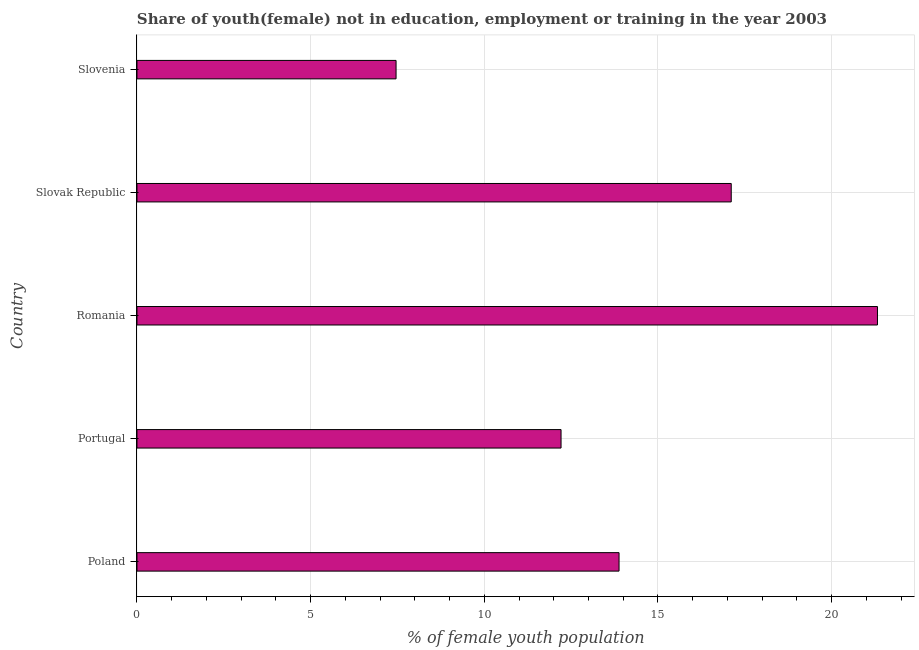Does the graph contain any zero values?
Keep it short and to the point. No. Does the graph contain grids?
Provide a short and direct response. Yes. What is the title of the graph?
Keep it short and to the point. Share of youth(female) not in education, employment or training in the year 2003. What is the label or title of the X-axis?
Your response must be concise. % of female youth population. What is the label or title of the Y-axis?
Make the answer very short. Country. What is the unemployed female youth population in Slovenia?
Provide a short and direct response. 7.46. Across all countries, what is the maximum unemployed female youth population?
Provide a short and direct response. 21.32. Across all countries, what is the minimum unemployed female youth population?
Provide a short and direct response. 7.46. In which country was the unemployed female youth population maximum?
Offer a terse response. Romania. In which country was the unemployed female youth population minimum?
Provide a short and direct response. Slovenia. What is the sum of the unemployed female youth population?
Provide a short and direct response. 71.98. What is the difference between the unemployed female youth population in Poland and Slovak Republic?
Your answer should be very brief. -3.23. What is the average unemployed female youth population per country?
Keep it short and to the point. 14.4. What is the median unemployed female youth population?
Your answer should be very brief. 13.88. In how many countries, is the unemployed female youth population greater than 6 %?
Give a very brief answer. 5. What is the ratio of the unemployed female youth population in Portugal to that in Slovak Republic?
Keep it short and to the point. 0.71. What is the difference between the highest and the second highest unemployed female youth population?
Give a very brief answer. 4.21. What is the difference between the highest and the lowest unemployed female youth population?
Your answer should be compact. 13.86. How many bars are there?
Make the answer very short. 5. Are all the bars in the graph horizontal?
Your response must be concise. Yes. What is the difference between two consecutive major ticks on the X-axis?
Keep it short and to the point. 5. Are the values on the major ticks of X-axis written in scientific E-notation?
Your answer should be compact. No. What is the % of female youth population of Poland?
Provide a succinct answer. 13.88. What is the % of female youth population of Portugal?
Ensure brevity in your answer.  12.21. What is the % of female youth population in Romania?
Provide a short and direct response. 21.32. What is the % of female youth population of Slovak Republic?
Your answer should be compact. 17.11. What is the % of female youth population of Slovenia?
Offer a terse response. 7.46. What is the difference between the % of female youth population in Poland and Portugal?
Provide a short and direct response. 1.67. What is the difference between the % of female youth population in Poland and Romania?
Give a very brief answer. -7.44. What is the difference between the % of female youth population in Poland and Slovak Republic?
Give a very brief answer. -3.23. What is the difference between the % of female youth population in Poland and Slovenia?
Ensure brevity in your answer.  6.42. What is the difference between the % of female youth population in Portugal and Romania?
Your answer should be very brief. -9.11. What is the difference between the % of female youth population in Portugal and Slovenia?
Your answer should be very brief. 4.75. What is the difference between the % of female youth population in Romania and Slovak Republic?
Offer a very short reply. 4.21. What is the difference between the % of female youth population in Romania and Slovenia?
Offer a very short reply. 13.86. What is the difference between the % of female youth population in Slovak Republic and Slovenia?
Keep it short and to the point. 9.65. What is the ratio of the % of female youth population in Poland to that in Portugal?
Ensure brevity in your answer.  1.14. What is the ratio of the % of female youth population in Poland to that in Romania?
Offer a very short reply. 0.65. What is the ratio of the % of female youth population in Poland to that in Slovak Republic?
Your response must be concise. 0.81. What is the ratio of the % of female youth population in Poland to that in Slovenia?
Give a very brief answer. 1.86. What is the ratio of the % of female youth population in Portugal to that in Romania?
Give a very brief answer. 0.57. What is the ratio of the % of female youth population in Portugal to that in Slovak Republic?
Your answer should be compact. 0.71. What is the ratio of the % of female youth population in Portugal to that in Slovenia?
Ensure brevity in your answer.  1.64. What is the ratio of the % of female youth population in Romania to that in Slovak Republic?
Ensure brevity in your answer.  1.25. What is the ratio of the % of female youth population in Romania to that in Slovenia?
Offer a very short reply. 2.86. What is the ratio of the % of female youth population in Slovak Republic to that in Slovenia?
Make the answer very short. 2.29. 